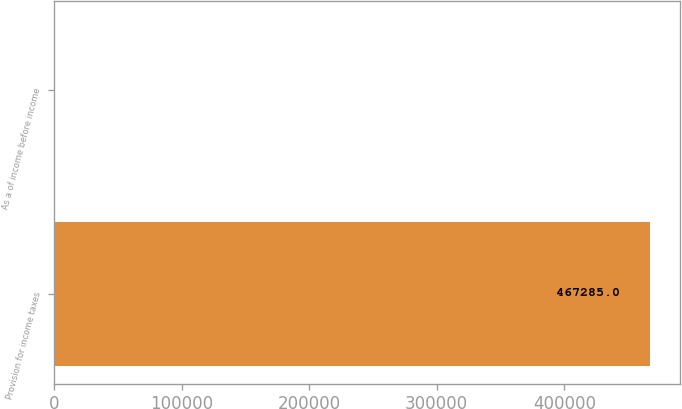<chart> <loc_0><loc_0><loc_500><loc_500><bar_chart><fcel>Provision for income taxes<fcel>As a of income before income<nl><fcel>467285<fcel>30<nl></chart> 